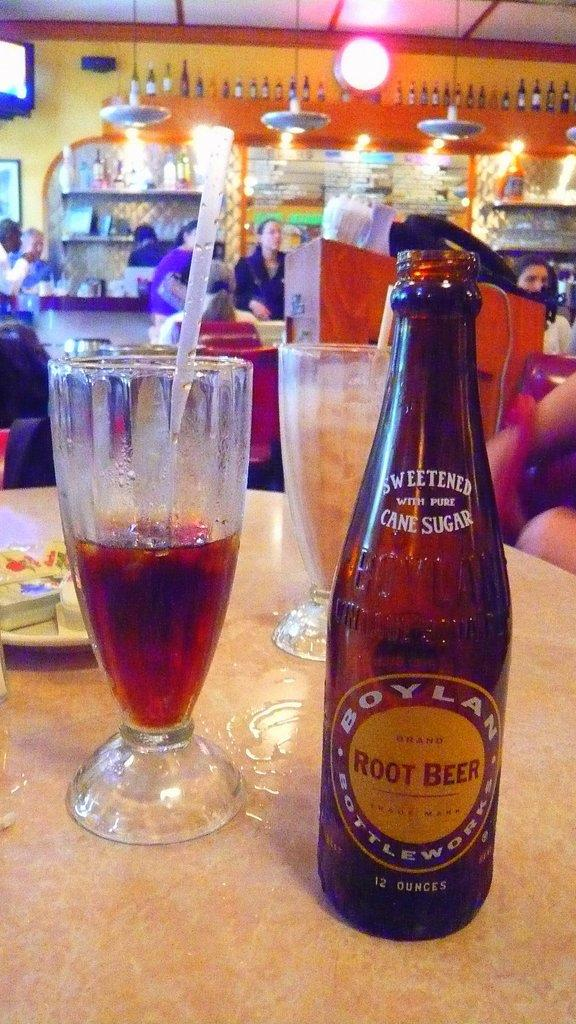<image>
Relay a brief, clear account of the picture shown. An open bottle of Boylan Root Beer next to a half-full glass. 